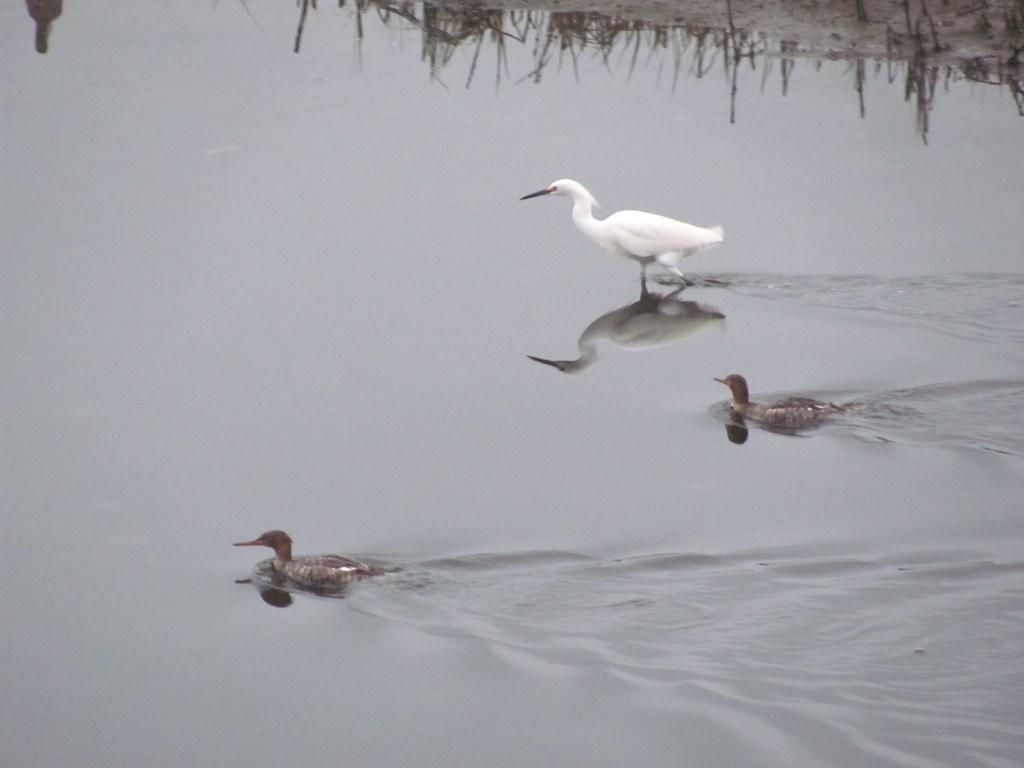In one or two sentences, can you explain what this image depicts? As we can see in the image there is water and three ducks. 